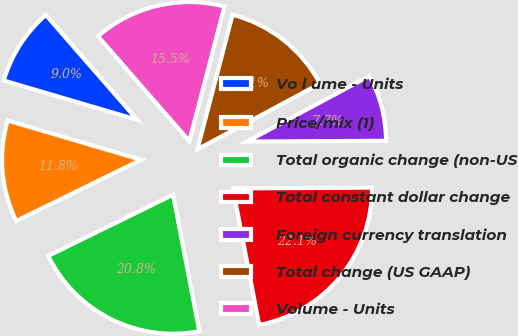Convert chart. <chart><loc_0><loc_0><loc_500><loc_500><pie_chart><fcel>Vo l ume - Units<fcel>Price/mix (1)<fcel>Total organic change (non-US<fcel>Total constant dollar change<fcel>Foreign currency translation<fcel>Total change (US GAAP)<fcel>Volume - Units<nl><fcel>9.04%<fcel>11.81%<fcel>20.77%<fcel>22.07%<fcel>7.74%<fcel>13.11%<fcel>15.47%<nl></chart> 